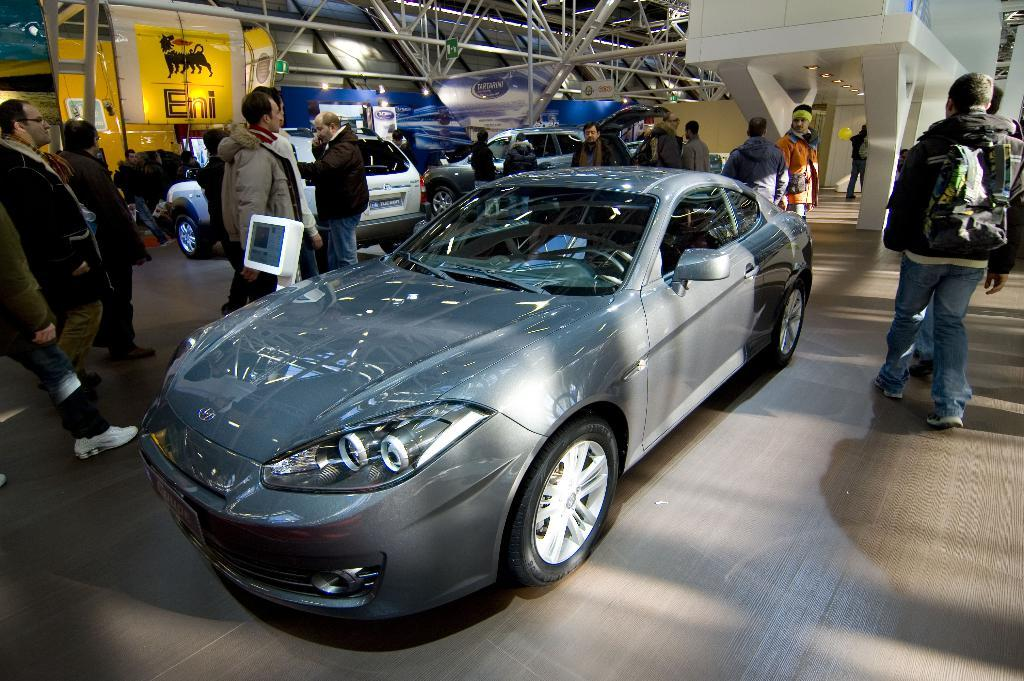What type of vehicles can be seen in the image? There are cars in the image. Who or what else is present in the image besides the cars? There is a group of people in the image. What can be seen in the background of the image? There are lights, hoardings, and metal rods in the background of the image. What type of reaction can be seen from the hole in the image? There is no hole present in the image, so it is not possible to observe any reaction from it. 